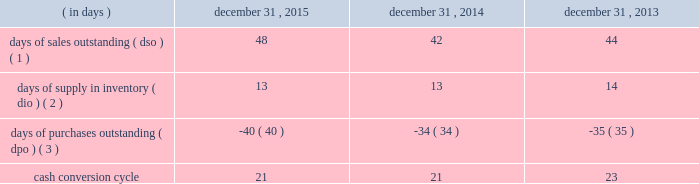Table of contents ( 4 ) the decline in cash flows was driven by the timing of inventory purchases at the end of 2014 versus 2013 .
In order to manage our working capital and operating cash needs , we monitor our cash conversion cycle , defined as days of sales outstanding in accounts receivable plus days of supply in inventory minus days of purchases outstanding in accounts payable , based on a rolling three-month average .
Components of our cash conversion cycle are as follows: .
( 1 ) represents the rolling three-month average of the balance of trade accounts receivable , net at the end of the period divided by average daily net sales for the same three-month period .
Also incorporates components of other miscellaneous receivables .
( 2 ) represents the rolling three-month average of the balance of merchandise inventory at the end of the period divided by average daily cost of goods sold for the same three-month period .
( 3 ) represents the rolling three-month average of the combined balance of accounts payable-trade , excluding cash overdrafts , and accounts payable-inventory financing at the end of the period divided by average daily cost of goods sold for the same three-month period .
The cash conversion cycle remained at 21 days at december 31 , 2015 and december 31 , 2014 .
The increase in dso was primarily driven by a higher accounts receivable balance at december 31 , 2015 driven by higher public segment sales where customers generally take longer to pay than customers in our corporate segment , slower government payments in certain states due to budget issues and an increase in net sales and related accounts receivable for third-party services such as software assurance and warranties .
These services have an unfavorable impact on dso as the receivable is recognized on the balance sheet on a gross basis while the corresponding sales amount in the statement of operations is recorded on a net basis .
These services have a favorable impact on dpo as the payable is recognized on the balance sheet without a corresponding cost of sale in the statement of operations because the cost paid to the vendor or third-party service provider is recorded as a reduction to net sales .
In addition to the impact of these services on dpo , dpo also increased due to the mix of payables with certain vendors that have longer payment terms .
The cash conversion cycle decreased to 21 days at december 31 , 2014 compared to 23 days at december 31 , 2013 , primarily driven by improvement in dso .
The decline in dso was primarily driven by improved collections and early payments from certain customers .
Additionally , the timing of inventory receipts at the end of 2014 had a favorable impact on dio and an unfavorable impact on dpo .
Investing activities net cash used in investing activities increased $ 189.6 million in 2015 compared to 2014 .
The increase was primarily due to the completion of the acquisition of kelway by purchasing the remaining 65% ( 65 % ) of its outstanding common stock on august 1 , 2015 .
Additionally , capital expenditures increased $ 35.1 million to $ 90.1 million from $ 55.0 million for 2015 and 2014 , respectively , primarily for our new office location and an increase in spending related to improvements to our information technology systems .
Net cash used in investing activities increased $ 117.7 million in 2014 compared to 2013 .
We paid $ 86.8 million in the fourth quarter of 2014 to acquire a 35% ( 35 % ) non-controlling interest in kelway .
Additionally , capital expenditures increased $ 7.9 million to $ 55.0 million from $ 47.1 million in 2014 and 2013 , respectively , primarily for improvements to our information technology systems during both years .
Financing activities net cash used in financing activities increased $ 114.5 million in 2015 compared to 2014 .
The increase was primarily driven by share repurchases during the year ended december 31 , 2015 which resulted in an increase in cash used for financing activities of $ 241.3 million .
For more information on our share repurchase program , see item 5 , 201cmarket for registrant 2019s common equity , related stockholder matters and issuer purchases of equity securities . 201d the increase was partially offset by the changes in accounts payable-inventory financing , which resulted in an increase in cash provided for financing activities of $ 20.4 million , and the net impact of our debt transactions which resulted in cash outflows of $ 7.1 million and $ 145.9 million during the years .
What was the three year average cash conversion cycle in days? 
Computations: table_average(cash conversion cycle, none)
Answer: 21.66667. 